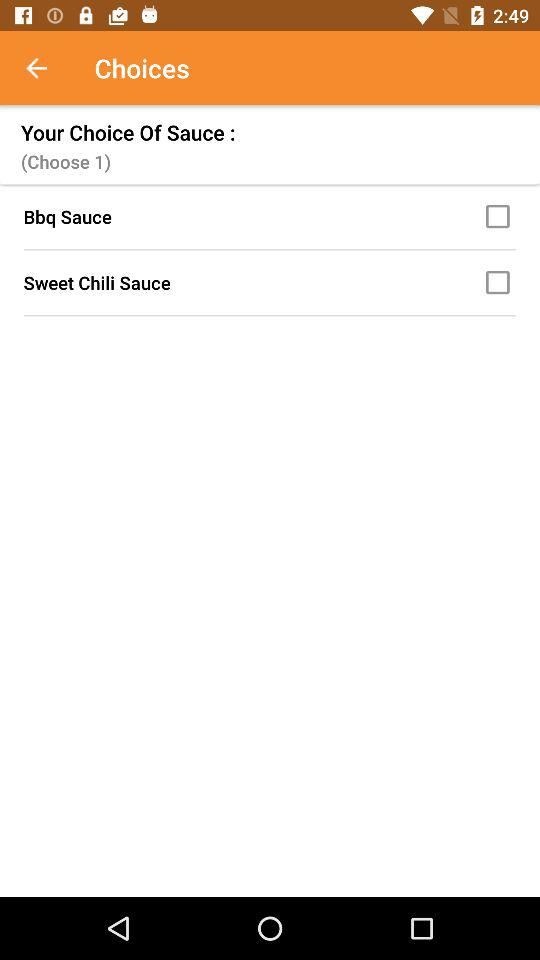What are the different available sauces? The different available sauces are "Bbq Sauce" and "Sweet Chili Sauce". 